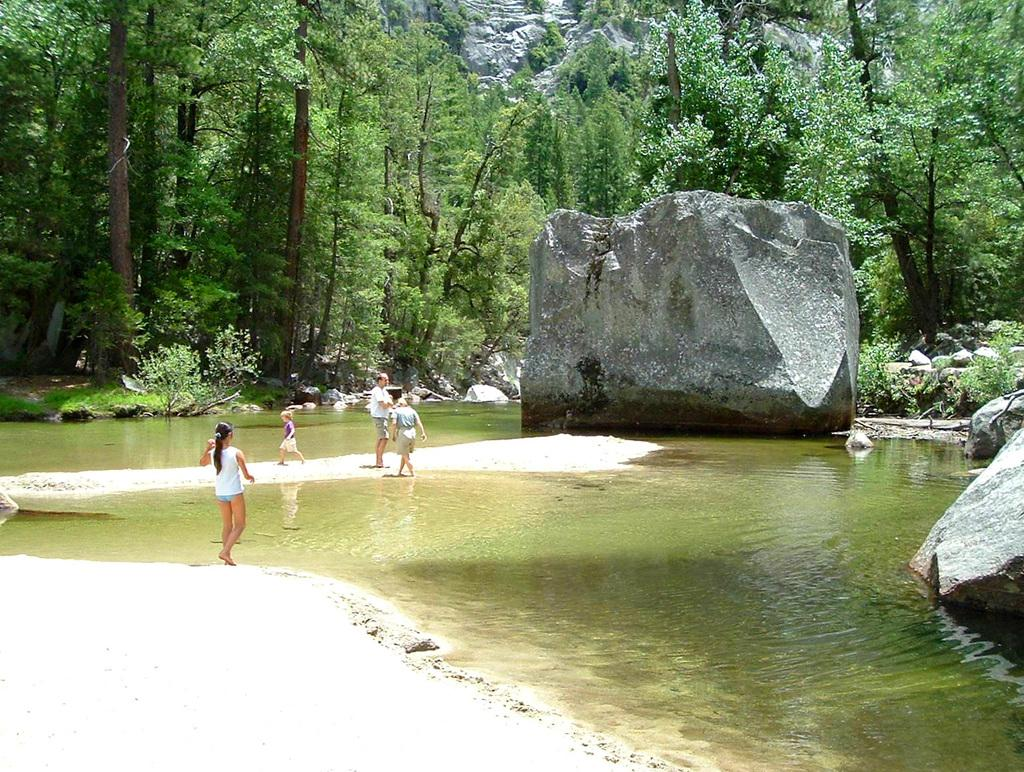How many people are present in the image? There are three people standing in the image. What is the child doing in the image? A child is walking on a path in the image. What can be seen in the background of the image? There are rocks and trees in the background of the image. Is there any water visible in the image? Yes, there is water visible in the image. What type of tub can be seen in the image? There is no tub present in the image. What is the best way to reach the destination shown in the image? The image does not provide enough information to determine the best way to reach the destination. 